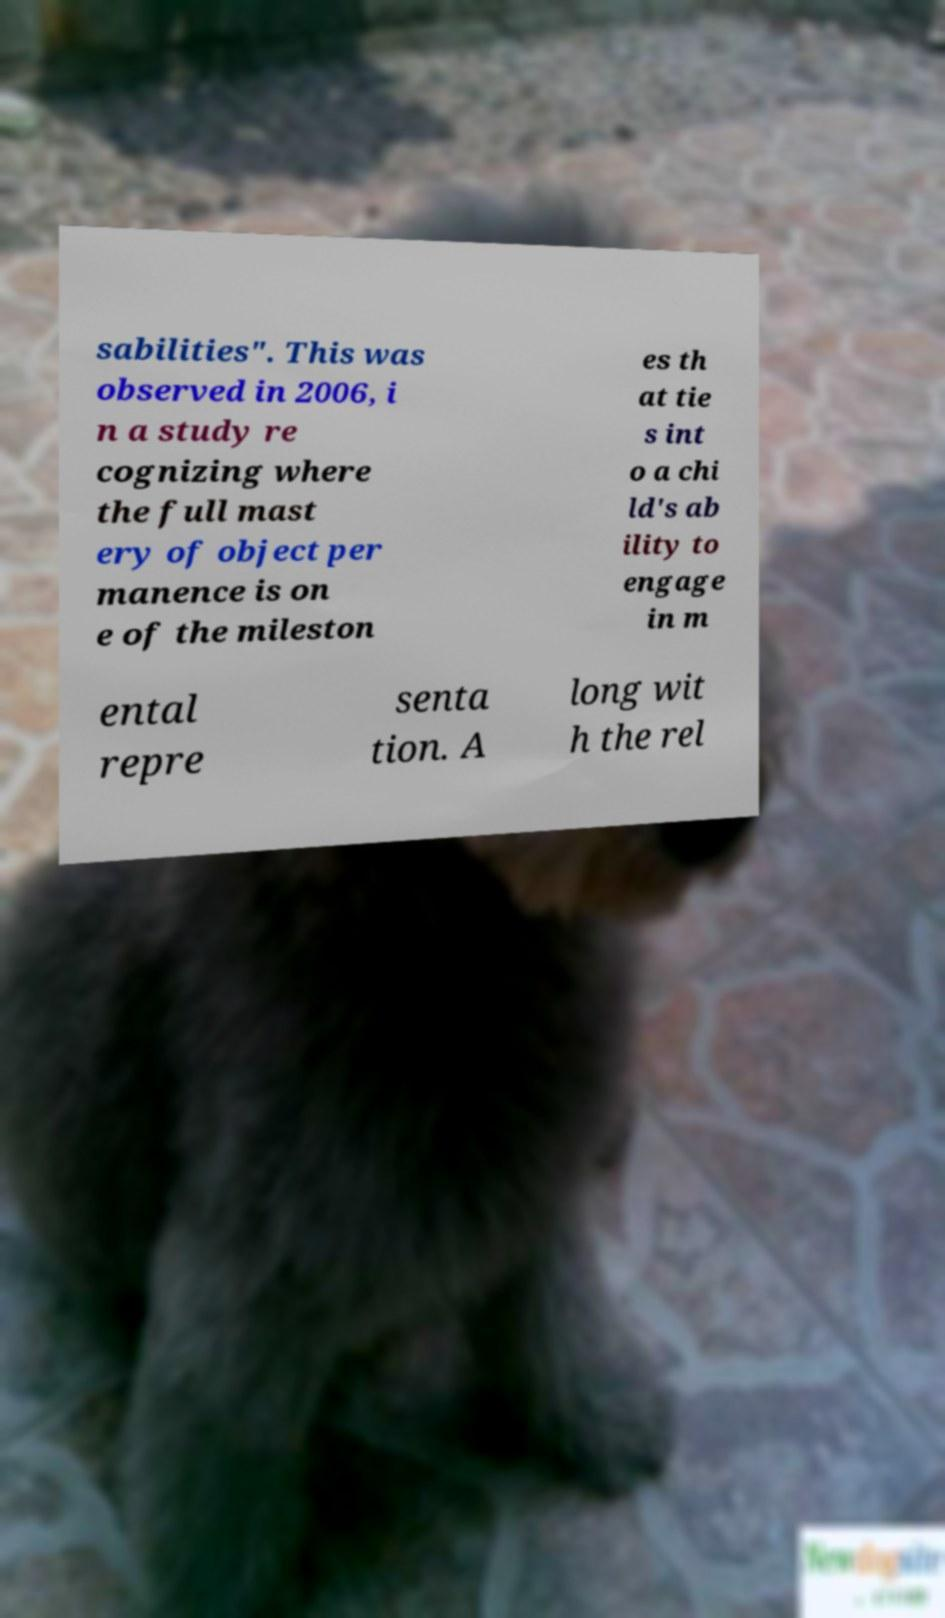For documentation purposes, I need the text within this image transcribed. Could you provide that? sabilities". This was observed in 2006, i n a study re cognizing where the full mast ery of object per manence is on e of the mileston es th at tie s int o a chi ld's ab ility to engage in m ental repre senta tion. A long wit h the rel 